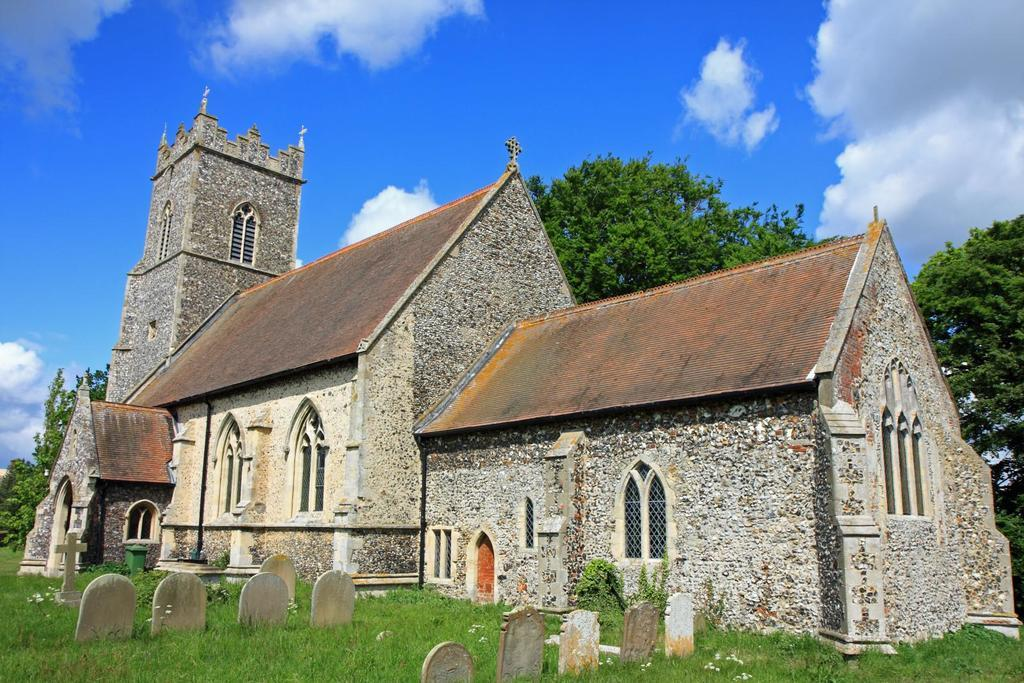What type of structures can be seen in the image? There are buildings in the image. What other natural elements are present in the image? There are trees and grass on the ground in the image. What might indicate that this is a cemetery? The presence of grave stones in the image suggests that it is a cemetery. How would you describe the weather in the image? The sky is blue and cloudy in the image, indicating a partly cloudy day. Can you hear the song that the ants are singing in the image? There are no ants or songs present in the image. What type of trail can be seen leading through the cemetery in the image? There is no trail visible in the image; it only shows buildings, trees, grass, grave stones, and the sky. 